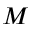Convert formula to latex. <formula><loc_0><loc_0><loc_500><loc_500>M</formula> 